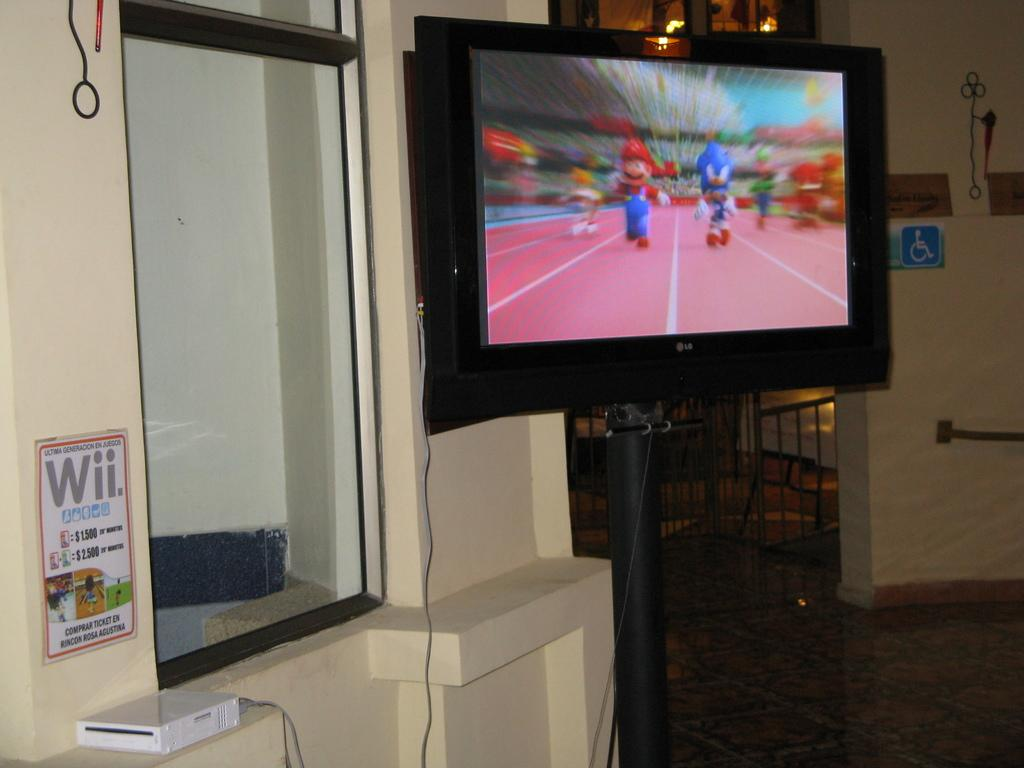<image>
Render a clear and concise summary of the photo. A TV that says LG on the front is showing Mario and Sonic the Hedgehog racing each other on foot. 